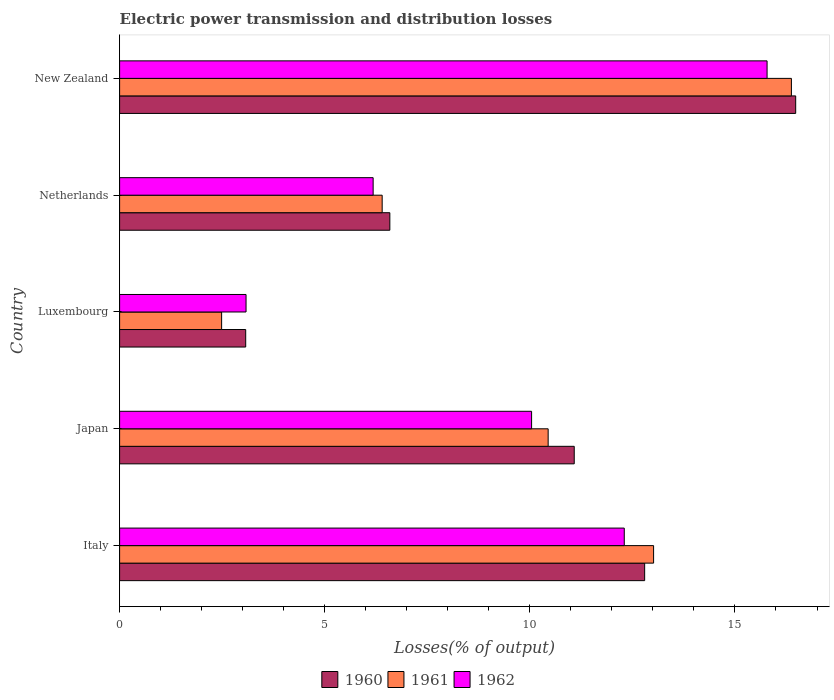How many bars are there on the 4th tick from the bottom?
Provide a succinct answer. 3. What is the label of the 4th group of bars from the top?
Offer a terse response. Japan. What is the electric power transmission and distribution losses in 1962 in Netherlands?
Your answer should be very brief. 6.18. Across all countries, what is the maximum electric power transmission and distribution losses in 1960?
Your answer should be very brief. 16.48. Across all countries, what is the minimum electric power transmission and distribution losses in 1960?
Provide a short and direct response. 3.07. In which country was the electric power transmission and distribution losses in 1960 maximum?
Provide a short and direct response. New Zealand. In which country was the electric power transmission and distribution losses in 1962 minimum?
Provide a succinct answer. Luxembourg. What is the total electric power transmission and distribution losses in 1962 in the graph?
Provide a succinct answer. 47.39. What is the difference between the electric power transmission and distribution losses in 1961 in Japan and that in New Zealand?
Offer a very short reply. -5.93. What is the difference between the electric power transmission and distribution losses in 1962 in New Zealand and the electric power transmission and distribution losses in 1961 in Netherlands?
Your answer should be compact. 9.38. What is the average electric power transmission and distribution losses in 1961 per country?
Your response must be concise. 9.75. What is the difference between the electric power transmission and distribution losses in 1960 and electric power transmission and distribution losses in 1962 in Japan?
Your answer should be compact. 1.04. In how many countries, is the electric power transmission and distribution losses in 1961 greater than 13 %?
Offer a terse response. 2. What is the ratio of the electric power transmission and distribution losses in 1960 in Luxembourg to that in New Zealand?
Provide a short and direct response. 0.19. Is the difference between the electric power transmission and distribution losses in 1960 in Japan and Luxembourg greater than the difference between the electric power transmission and distribution losses in 1962 in Japan and Luxembourg?
Your answer should be very brief. Yes. What is the difference between the highest and the second highest electric power transmission and distribution losses in 1960?
Your response must be concise. 3.68. What is the difference between the highest and the lowest electric power transmission and distribution losses in 1961?
Keep it short and to the point. 13.89. Is the sum of the electric power transmission and distribution losses in 1961 in Italy and New Zealand greater than the maximum electric power transmission and distribution losses in 1960 across all countries?
Provide a succinct answer. Yes. How many bars are there?
Ensure brevity in your answer.  15. Are the values on the major ticks of X-axis written in scientific E-notation?
Provide a short and direct response. No. Does the graph contain grids?
Ensure brevity in your answer.  No. How many legend labels are there?
Ensure brevity in your answer.  3. How are the legend labels stacked?
Offer a very short reply. Horizontal. What is the title of the graph?
Your answer should be very brief. Electric power transmission and distribution losses. Does "1976" appear as one of the legend labels in the graph?
Offer a terse response. No. What is the label or title of the X-axis?
Provide a short and direct response. Losses(% of output). What is the label or title of the Y-axis?
Provide a short and direct response. Country. What is the Losses(% of output) in 1960 in Italy?
Give a very brief answer. 12.8. What is the Losses(% of output) in 1961 in Italy?
Ensure brevity in your answer.  13.02. What is the Losses(% of output) of 1962 in Italy?
Ensure brevity in your answer.  12.3. What is the Losses(% of output) of 1960 in Japan?
Offer a very short reply. 11.08. What is the Losses(% of output) of 1961 in Japan?
Make the answer very short. 10.45. What is the Losses(% of output) in 1962 in Japan?
Keep it short and to the point. 10.04. What is the Losses(% of output) of 1960 in Luxembourg?
Offer a very short reply. 3.07. What is the Losses(% of output) of 1961 in Luxembourg?
Keep it short and to the point. 2.49. What is the Losses(% of output) of 1962 in Luxembourg?
Ensure brevity in your answer.  3.08. What is the Losses(% of output) in 1960 in Netherlands?
Your response must be concise. 6.59. What is the Losses(% of output) in 1961 in Netherlands?
Your answer should be very brief. 6.4. What is the Losses(% of output) in 1962 in Netherlands?
Give a very brief answer. 6.18. What is the Losses(% of output) in 1960 in New Zealand?
Give a very brief answer. 16.48. What is the Losses(% of output) in 1961 in New Zealand?
Make the answer very short. 16.38. What is the Losses(% of output) in 1962 in New Zealand?
Provide a short and direct response. 15.78. Across all countries, what is the maximum Losses(% of output) in 1960?
Keep it short and to the point. 16.48. Across all countries, what is the maximum Losses(% of output) in 1961?
Offer a very short reply. 16.38. Across all countries, what is the maximum Losses(% of output) of 1962?
Provide a short and direct response. 15.78. Across all countries, what is the minimum Losses(% of output) in 1960?
Your response must be concise. 3.07. Across all countries, what is the minimum Losses(% of output) in 1961?
Ensure brevity in your answer.  2.49. Across all countries, what is the minimum Losses(% of output) in 1962?
Your answer should be very brief. 3.08. What is the total Losses(% of output) in 1960 in the graph?
Give a very brief answer. 50.02. What is the total Losses(% of output) in 1961 in the graph?
Your response must be concise. 48.73. What is the total Losses(% of output) in 1962 in the graph?
Provide a short and direct response. 47.39. What is the difference between the Losses(% of output) in 1960 in Italy and that in Japan?
Offer a very short reply. 1.72. What is the difference between the Losses(% of output) in 1961 in Italy and that in Japan?
Ensure brevity in your answer.  2.57. What is the difference between the Losses(% of output) of 1962 in Italy and that in Japan?
Your response must be concise. 2.26. What is the difference between the Losses(% of output) in 1960 in Italy and that in Luxembourg?
Offer a terse response. 9.72. What is the difference between the Losses(% of output) of 1961 in Italy and that in Luxembourg?
Ensure brevity in your answer.  10.53. What is the difference between the Losses(% of output) of 1962 in Italy and that in Luxembourg?
Give a very brief answer. 9.22. What is the difference between the Losses(% of output) in 1960 in Italy and that in Netherlands?
Your response must be concise. 6.21. What is the difference between the Losses(% of output) of 1961 in Italy and that in Netherlands?
Provide a short and direct response. 6.62. What is the difference between the Losses(% of output) in 1962 in Italy and that in Netherlands?
Provide a short and direct response. 6.12. What is the difference between the Losses(% of output) in 1960 in Italy and that in New Zealand?
Provide a succinct answer. -3.68. What is the difference between the Losses(% of output) of 1961 in Italy and that in New Zealand?
Offer a very short reply. -3.36. What is the difference between the Losses(% of output) in 1962 in Italy and that in New Zealand?
Your response must be concise. -3.48. What is the difference between the Losses(% of output) in 1960 in Japan and that in Luxembourg?
Keep it short and to the point. 8.01. What is the difference between the Losses(% of output) of 1961 in Japan and that in Luxembourg?
Make the answer very short. 7.96. What is the difference between the Losses(% of output) of 1962 in Japan and that in Luxembourg?
Provide a short and direct response. 6.96. What is the difference between the Losses(% of output) of 1960 in Japan and that in Netherlands?
Your response must be concise. 4.49. What is the difference between the Losses(% of output) of 1961 in Japan and that in Netherlands?
Provide a succinct answer. 4.05. What is the difference between the Losses(% of output) of 1962 in Japan and that in Netherlands?
Provide a short and direct response. 3.86. What is the difference between the Losses(% of output) of 1960 in Japan and that in New Zealand?
Your answer should be very brief. -5.4. What is the difference between the Losses(% of output) in 1961 in Japan and that in New Zealand?
Ensure brevity in your answer.  -5.93. What is the difference between the Losses(% of output) in 1962 in Japan and that in New Zealand?
Your answer should be compact. -5.74. What is the difference between the Losses(% of output) of 1960 in Luxembourg and that in Netherlands?
Offer a terse response. -3.51. What is the difference between the Losses(% of output) in 1961 in Luxembourg and that in Netherlands?
Provide a short and direct response. -3.91. What is the difference between the Losses(% of output) of 1962 in Luxembourg and that in Netherlands?
Provide a short and direct response. -3.1. What is the difference between the Losses(% of output) in 1960 in Luxembourg and that in New Zealand?
Your answer should be very brief. -13.41. What is the difference between the Losses(% of output) in 1961 in Luxembourg and that in New Zealand?
Your response must be concise. -13.89. What is the difference between the Losses(% of output) of 1962 in Luxembourg and that in New Zealand?
Provide a succinct answer. -12.7. What is the difference between the Losses(% of output) in 1960 in Netherlands and that in New Zealand?
Your response must be concise. -9.89. What is the difference between the Losses(% of output) in 1961 in Netherlands and that in New Zealand?
Your answer should be compact. -9.98. What is the difference between the Losses(% of output) in 1962 in Netherlands and that in New Zealand?
Give a very brief answer. -9.6. What is the difference between the Losses(% of output) of 1960 in Italy and the Losses(% of output) of 1961 in Japan?
Provide a succinct answer. 2.35. What is the difference between the Losses(% of output) in 1960 in Italy and the Losses(% of output) in 1962 in Japan?
Your answer should be compact. 2.76. What is the difference between the Losses(% of output) of 1961 in Italy and the Losses(% of output) of 1962 in Japan?
Offer a very short reply. 2.97. What is the difference between the Losses(% of output) in 1960 in Italy and the Losses(% of output) in 1961 in Luxembourg?
Ensure brevity in your answer.  10.31. What is the difference between the Losses(% of output) in 1960 in Italy and the Losses(% of output) in 1962 in Luxembourg?
Your answer should be very brief. 9.72. What is the difference between the Losses(% of output) of 1961 in Italy and the Losses(% of output) of 1962 in Luxembourg?
Provide a succinct answer. 9.93. What is the difference between the Losses(% of output) of 1960 in Italy and the Losses(% of output) of 1961 in Netherlands?
Give a very brief answer. 6.4. What is the difference between the Losses(% of output) of 1960 in Italy and the Losses(% of output) of 1962 in Netherlands?
Your answer should be very brief. 6.62. What is the difference between the Losses(% of output) of 1961 in Italy and the Losses(% of output) of 1962 in Netherlands?
Offer a very short reply. 6.84. What is the difference between the Losses(% of output) of 1960 in Italy and the Losses(% of output) of 1961 in New Zealand?
Ensure brevity in your answer.  -3.58. What is the difference between the Losses(% of output) of 1960 in Italy and the Losses(% of output) of 1962 in New Zealand?
Give a very brief answer. -2.98. What is the difference between the Losses(% of output) of 1961 in Italy and the Losses(% of output) of 1962 in New Zealand?
Provide a short and direct response. -2.77. What is the difference between the Losses(% of output) of 1960 in Japan and the Losses(% of output) of 1961 in Luxembourg?
Your answer should be compact. 8.6. What is the difference between the Losses(% of output) of 1960 in Japan and the Losses(% of output) of 1962 in Luxembourg?
Make the answer very short. 8. What is the difference between the Losses(% of output) of 1961 in Japan and the Losses(% of output) of 1962 in Luxembourg?
Ensure brevity in your answer.  7.36. What is the difference between the Losses(% of output) in 1960 in Japan and the Losses(% of output) in 1961 in Netherlands?
Provide a succinct answer. 4.68. What is the difference between the Losses(% of output) of 1960 in Japan and the Losses(% of output) of 1962 in Netherlands?
Ensure brevity in your answer.  4.9. What is the difference between the Losses(% of output) in 1961 in Japan and the Losses(% of output) in 1962 in Netherlands?
Keep it short and to the point. 4.27. What is the difference between the Losses(% of output) in 1960 in Japan and the Losses(% of output) in 1961 in New Zealand?
Provide a succinct answer. -5.29. What is the difference between the Losses(% of output) in 1960 in Japan and the Losses(% of output) in 1962 in New Zealand?
Give a very brief answer. -4.7. What is the difference between the Losses(% of output) of 1961 in Japan and the Losses(% of output) of 1962 in New Zealand?
Your answer should be compact. -5.34. What is the difference between the Losses(% of output) in 1960 in Luxembourg and the Losses(% of output) in 1961 in Netherlands?
Your response must be concise. -3.33. What is the difference between the Losses(% of output) of 1960 in Luxembourg and the Losses(% of output) of 1962 in Netherlands?
Your answer should be compact. -3.11. What is the difference between the Losses(% of output) in 1961 in Luxembourg and the Losses(% of output) in 1962 in Netherlands?
Keep it short and to the point. -3.69. What is the difference between the Losses(% of output) in 1960 in Luxembourg and the Losses(% of output) in 1961 in New Zealand?
Offer a very short reply. -13.3. What is the difference between the Losses(% of output) of 1960 in Luxembourg and the Losses(% of output) of 1962 in New Zealand?
Offer a very short reply. -12.71. What is the difference between the Losses(% of output) in 1961 in Luxembourg and the Losses(% of output) in 1962 in New Zealand?
Ensure brevity in your answer.  -13.3. What is the difference between the Losses(% of output) in 1960 in Netherlands and the Losses(% of output) in 1961 in New Zealand?
Provide a short and direct response. -9.79. What is the difference between the Losses(% of output) of 1960 in Netherlands and the Losses(% of output) of 1962 in New Zealand?
Offer a terse response. -9.2. What is the difference between the Losses(% of output) of 1961 in Netherlands and the Losses(% of output) of 1962 in New Zealand?
Provide a short and direct response. -9.38. What is the average Losses(% of output) of 1960 per country?
Your response must be concise. 10. What is the average Losses(% of output) in 1961 per country?
Offer a terse response. 9.75. What is the average Losses(% of output) in 1962 per country?
Your response must be concise. 9.48. What is the difference between the Losses(% of output) of 1960 and Losses(% of output) of 1961 in Italy?
Ensure brevity in your answer.  -0.22. What is the difference between the Losses(% of output) in 1960 and Losses(% of output) in 1962 in Italy?
Make the answer very short. 0.5. What is the difference between the Losses(% of output) in 1961 and Losses(% of output) in 1962 in Italy?
Your response must be concise. 0.71. What is the difference between the Losses(% of output) of 1960 and Losses(% of output) of 1961 in Japan?
Offer a terse response. 0.64. What is the difference between the Losses(% of output) in 1960 and Losses(% of output) in 1962 in Japan?
Provide a short and direct response. 1.04. What is the difference between the Losses(% of output) in 1961 and Losses(% of output) in 1962 in Japan?
Provide a short and direct response. 0.4. What is the difference between the Losses(% of output) of 1960 and Losses(% of output) of 1961 in Luxembourg?
Your answer should be compact. 0.59. What is the difference between the Losses(% of output) of 1960 and Losses(% of output) of 1962 in Luxembourg?
Keep it short and to the point. -0.01. What is the difference between the Losses(% of output) in 1961 and Losses(% of output) in 1962 in Luxembourg?
Your answer should be compact. -0.6. What is the difference between the Losses(% of output) of 1960 and Losses(% of output) of 1961 in Netherlands?
Offer a terse response. 0.19. What is the difference between the Losses(% of output) of 1960 and Losses(% of output) of 1962 in Netherlands?
Your response must be concise. 0.41. What is the difference between the Losses(% of output) of 1961 and Losses(% of output) of 1962 in Netherlands?
Offer a very short reply. 0.22. What is the difference between the Losses(% of output) of 1960 and Losses(% of output) of 1961 in New Zealand?
Make the answer very short. 0.1. What is the difference between the Losses(% of output) of 1960 and Losses(% of output) of 1962 in New Zealand?
Offer a terse response. 0.7. What is the difference between the Losses(% of output) in 1961 and Losses(% of output) in 1962 in New Zealand?
Provide a succinct answer. 0.59. What is the ratio of the Losses(% of output) of 1960 in Italy to that in Japan?
Your response must be concise. 1.15. What is the ratio of the Losses(% of output) in 1961 in Italy to that in Japan?
Make the answer very short. 1.25. What is the ratio of the Losses(% of output) of 1962 in Italy to that in Japan?
Your answer should be very brief. 1.23. What is the ratio of the Losses(% of output) in 1960 in Italy to that in Luxembourg?
Offer a very short reply. 4.16. What is the ratio of the Losses(% of output) in 1961 in Italy to that in Luxembourg?
Ensure brevity in your answer.  5.23. What is the ratio of the Losses(% of output) in 1962 in Italy to that in Luxembourg?
Keep it short and to the point. 3.99. What is the ratio of the Losses(% of output) in 1960 in Italy to that in Netherlands?
Your answer should be compact. 1.94. What is the ratio of the Losses(% of output) in 1961 in Italy to that in Netherlands?
Give a very brief answer. 2.03. What is the ratio of the Losses(% of output) in 1962 in Italy to that in Netherlands?
Provide a short and direct response. 1.99. What is the ratio of the Losses(% of output) of 1960 in Italy to that in New Zealand?
Offer a terse response. 0.78. What is the ratio of the Losses(% of output) in 1961 in Italy to that in New Zealand?
Provide a succinct answer. 0.79. What is the ratio of the Losses(% of output) of 1962 in Italy to that in New Zealand?
Offer a very short reply. 0.78. What is the ratio of the Losses(% of output) in 1960 in Japan to that in Luxembourg?
Your answer should be compact. 3.61. What is the ratio of the Losses(% of output) of 1961 in Japan to that in Luxembourg?
Ensure brevity in your answer.  4.2. What is the ratio of the Losses(% of output) in 1962 in Japan to that in Luxembourg?
Give a very brief answer. 3.26. What is the ratio of the Losses(% of output) of 1960 in Japan to that in Netherlands?
Your answer should be compact. 1.68. What is the ratio of the Losses(% of output) in 1961 in Japan to that in Netherlands?
Give a very brief answer. 1.63. What is the ratio of the Losses(% of output) of 1962 in Japan to that in Netherlands?
Make the answer very short. 1.62. What is the ratio of the Losses(% of output) of 1960 in Japan to that in New Zealand?
Provide a short and direct response. 0.67. What is the ratio of the Losses(% of output) in 1961 in Japan to that in New Zealand?
Provide a succinct answer. 0.64. What is the ratio of the Losses(% of output) in 1962 in Japan to that in New Zealand?
Provide a succinct answer. 0.64. What is the ratio of the Losses(% of output) in 1960 in Luxembourg to that in Netherlands?
Offer a very short reply. 0.47. What is the ratio of the Losses(% of output) of 1961 in Luxembourg to that in Netherlands?
Make the answer very short. 0.39. What is the ratio of the Losses(% of output) in 1962 in Luxembourg to that in Netherlands?
Ensure brevity in your answer.  0.5. What is the ratio of the Losses(% of output) of 1960 in Luxembourg to that in New Zealand?
Keep it short and to the point. 0.19. What is the ratio of the Losses(% of output) of 1961 in Luxembourg to that in New Zealand?
Provide a short and direct response. 0.15. What is the ratio of the Losses(% of output) of 1962 in Luxembourg to that in New Zealand?
Your response must be concise. 0.2. What is the ratio of the Losses(% of output) of 1960 in Netherlands to that in New Zealand?
Keep it short and to the point. 0.4. What is the ratio of the Losses(% of output) of 1961 in Netherlands to that in New Zealand?
Offer a very short reply. 0.39. What is the ratio of the Losses(% of output) of 1962 in Netherlands to that in New Zealand?
Offer a terse response. 0.39. What is the difference between the highest and the second highest Losses(% of output) of 1960?
Your answer should be very brief. 3.68. What is the difference between the highest and the second highest Losses(% of output) in 1961?
Your answer should be compact. 3.36. What is the difference between the highest and the second highest Losses(% of output) of 1962?
Your answer should be compact. 3.48. What is the difference between the highest and the lowest Losses(% of output) in 1960?
Give a very brief answer. 13.41. What is the difference between the highest and the lowest Losses(% of output) in 1961?
Provide a short and direct response. 13.89. What is the difference between the highest and the lowest Losses(% of output) of 1962?
Provide a succinct answer. 12.7. 